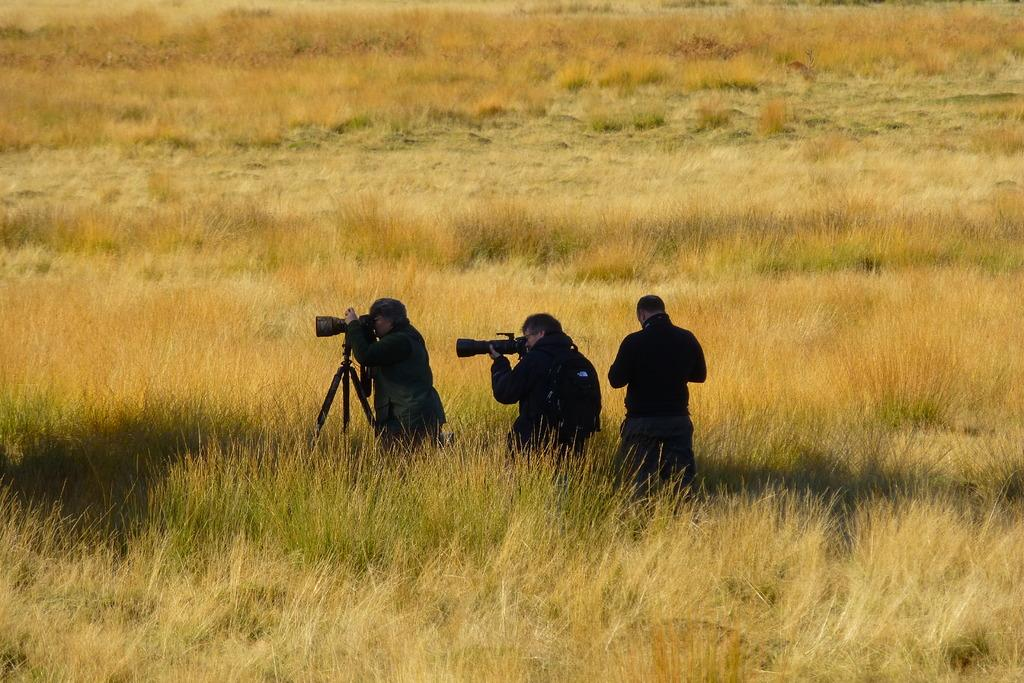How many people are in the image? There are three people in the image. What are the people holding in the image? The people are holding cameras. Where are the people standing in the image? The people are standing in the grass. What else related to photography can be seen in the image? There is a camera stand in the image. What degree do the people in the image have in photography? The provided facts do not mention any degrees or qualifications of the people in the image, so we cannot determine their level of education in photography. 